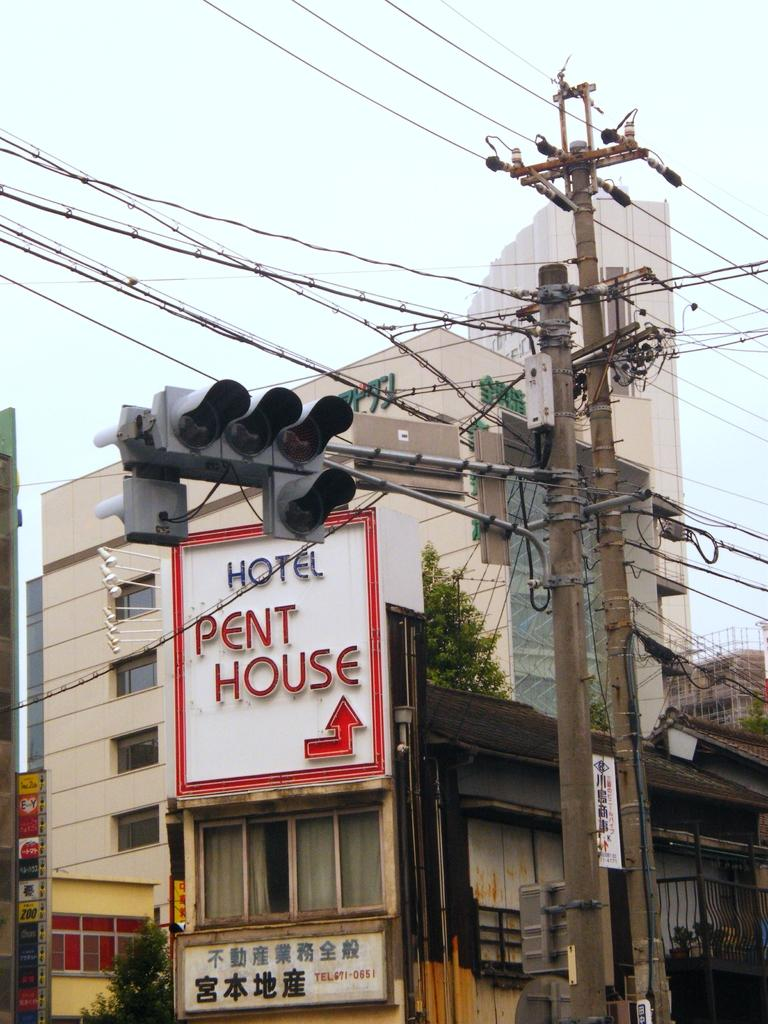What type of structures can be seen in the image? There are electrical poles, a traffic signal, buildings, and shop boards visible in the image. What else can be seen in the image besides structures? There are wires, trees, and possibly other elements in the image. Can you describe the traffic signal in the image? The traffic signal is likely used to control the flow of traffic at an intersection or road. What is the current debt situation of the shop owners in the image? There is no information about the debt situation of the shop owners in the image, as it does not contain any details about their financial status. 